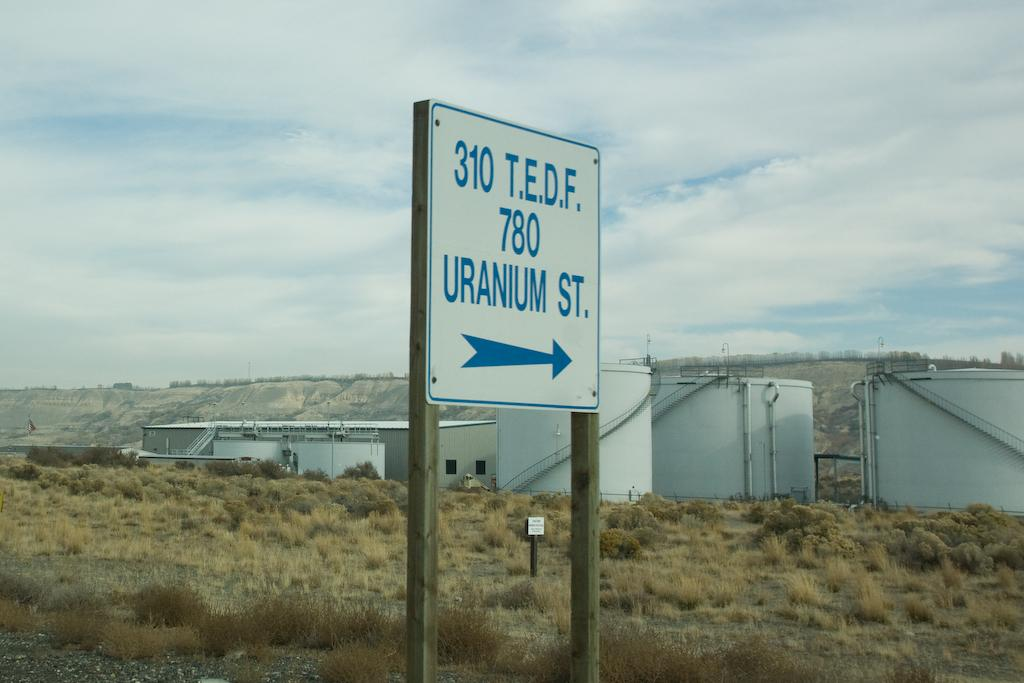Provide a one-sentence caption for the provided image. White sign with blue border says 310 T.E.D.F. 780  Uranium St. with blue arrow pointing right. 